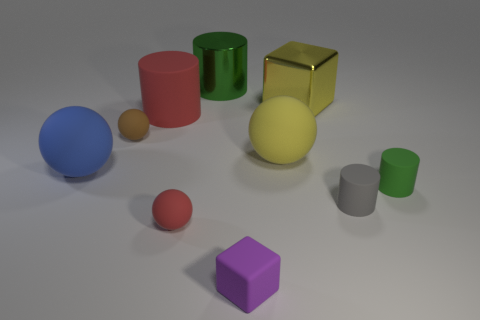The metal thing that is the same size as the yellow block is what color?
Make the answer very short. Green. What is the color of the big thing that is in front of the big red matte object and to the right of the blue matte ball?
Offer a very short reply. Yellow. The sphere that is the same color as the metallic block is what size?
Offer a terse response. Large. There is a rubber object that is the same color as the large metal cylinder; what shape is it?
Keep it short and to the point. Cylinder. There is a cube in front of the yellow object that is in front of the large metallic thing to the right of the small purple rubber object; how big is it?
Your answer should be very brief. Small. What material is the large blue sphere?
Your answer should be very brief. Rubber. Is the purple thing made of the same material as the large cube that is behind the small brown sphere?
Your answer should be very brief. No. Is there any other thing that is the same color as the big block?
Give a very brief answer. Yes. There is a green object to the left of the rubber thing right of the gray thing; are there any brown rubber things that are behind it?
Make the answer very short. No. What is the color of the metal block?
Ensure brevity in your answer.  Yellow. 